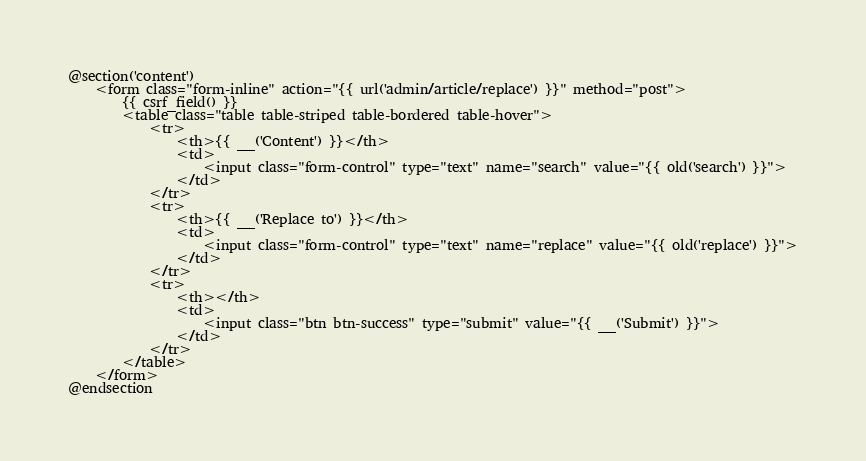Convert code to text. <code><loc_0><loc_0><loc_500><loc_500><_PHP_>
@section('content')
    <form class="form-inline" action="{{ url('admin/article/replace') }}" method="post">
        {{ csrf_field() }}
        <table class="table table-striped table-bordered table-hover">
            <tr>
                <th>{{ __('Content') }}</th>
                <td>
                    <input class="form-control" type="text" name="search" value="{{ old('search') }}">
                </td>
            </tr>
            <tr>
                <th>{{ __('Replace to') }}</th>
                <td>
                    <input class="form-control" type="text" name="replace" value="{{ old('replace') }}">
                </td>
            </tr>
            <tr>
                <th></th>
                <td>
                    <input class="btn btn-success" type="submit" value="{{ __('Submit') }}">
                </td>
            </tr>
        </table>
    </form>
@endsection
</code> 